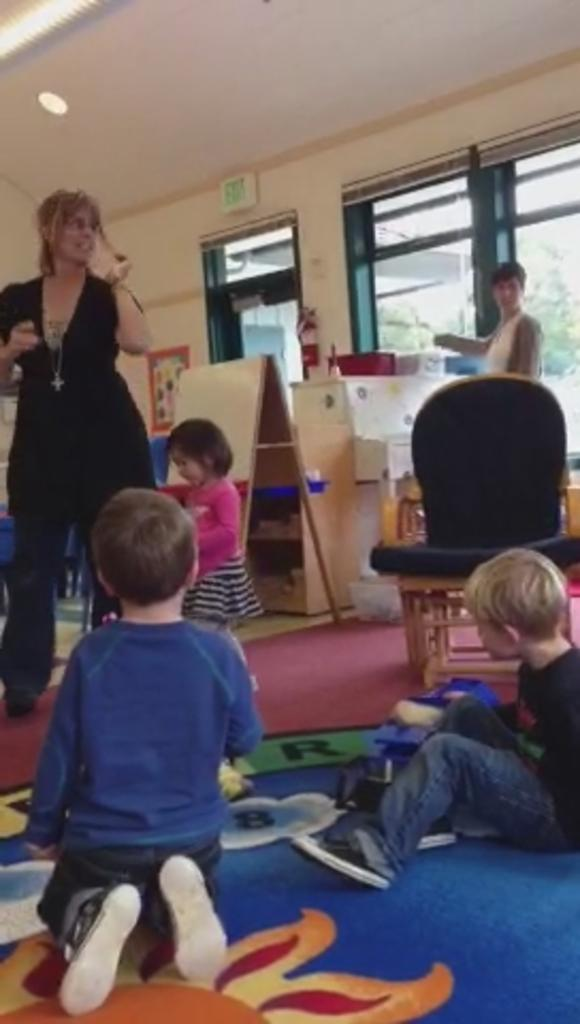What type of structure can be seen in the image? There is a wall in the image. Are there any openings in the wall? Yes, there are windows in the image. What else can be seen in the image besides the wall and windows? There are people standing in the image. Can you describe any furniture in the image? There is a chair on the right side of the image. What type of cake is being served on the chin of the person in the image? There is no cake or person with a cake on their chin present in the image. 